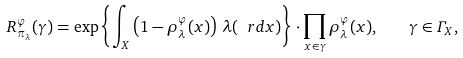Convert formula to latex. <formula><loc_0><loc_0><loc_500><loc_500>R _ { \pi _ { \lambda } } ^ { \varphi } ( \gamma ) = \exp \left \{ \int _ { X } \left ( 1 - \rho _ { \lambda } ^ { \varphi } ( x ) \right ) \, \lambda ( \ r d x ) \right \} \cdot \prod _ { x \in \gamma } \rho _ { \lambda } ^ { \varphi } ( x ) , \quad \gamma \in \varGamma _ { X } ,</formula> 